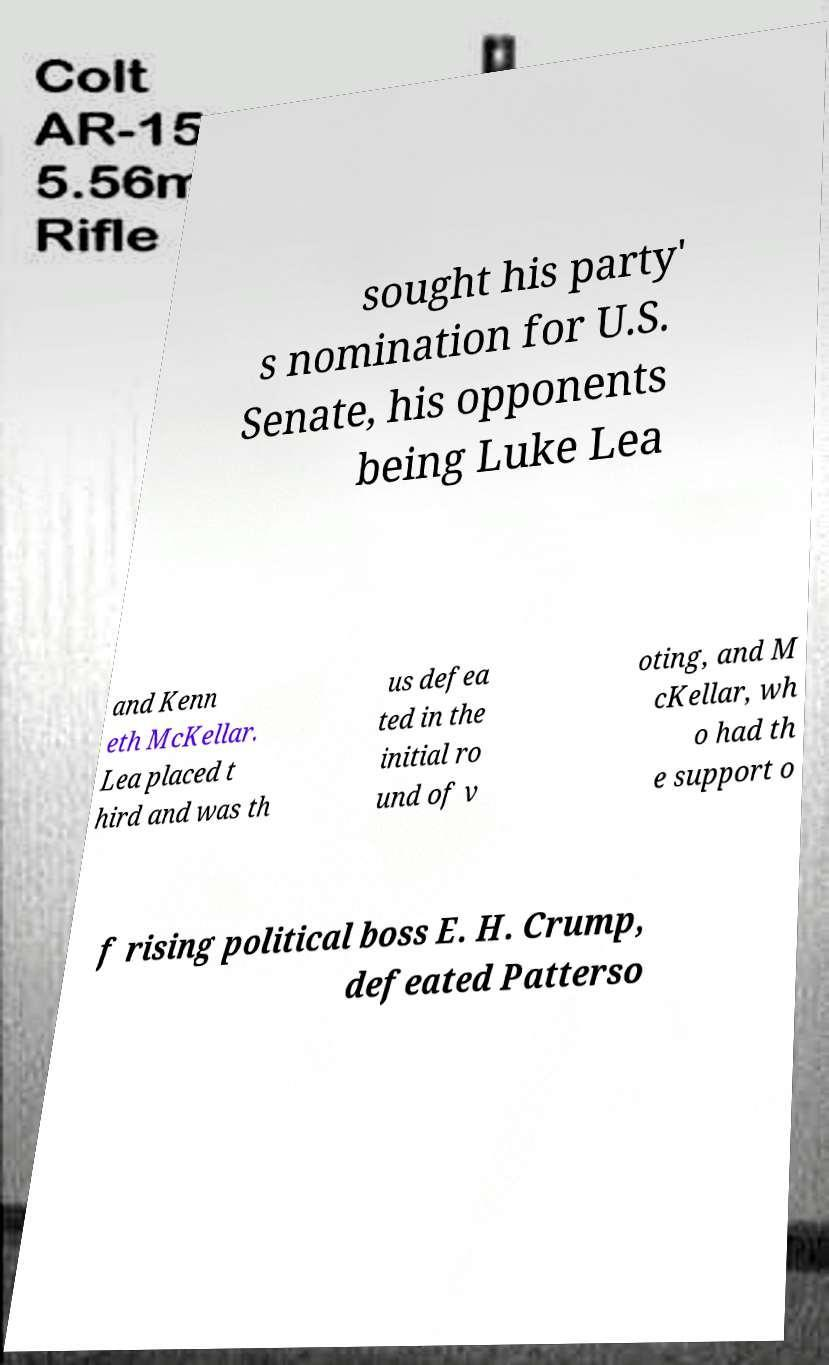There's text embedded in this image that I need extracted. Can you transcribe it verbatim? sought his party' s nomination for U.S. Senate, his opponents being Luke Lea and Kenn eth McKellar. Lea placed t hird and was th us defea ted in the initial ro und of v oting, and M cKellar, wh o had th e support o f rising political boss E. H. Crump, defeated Patterso 